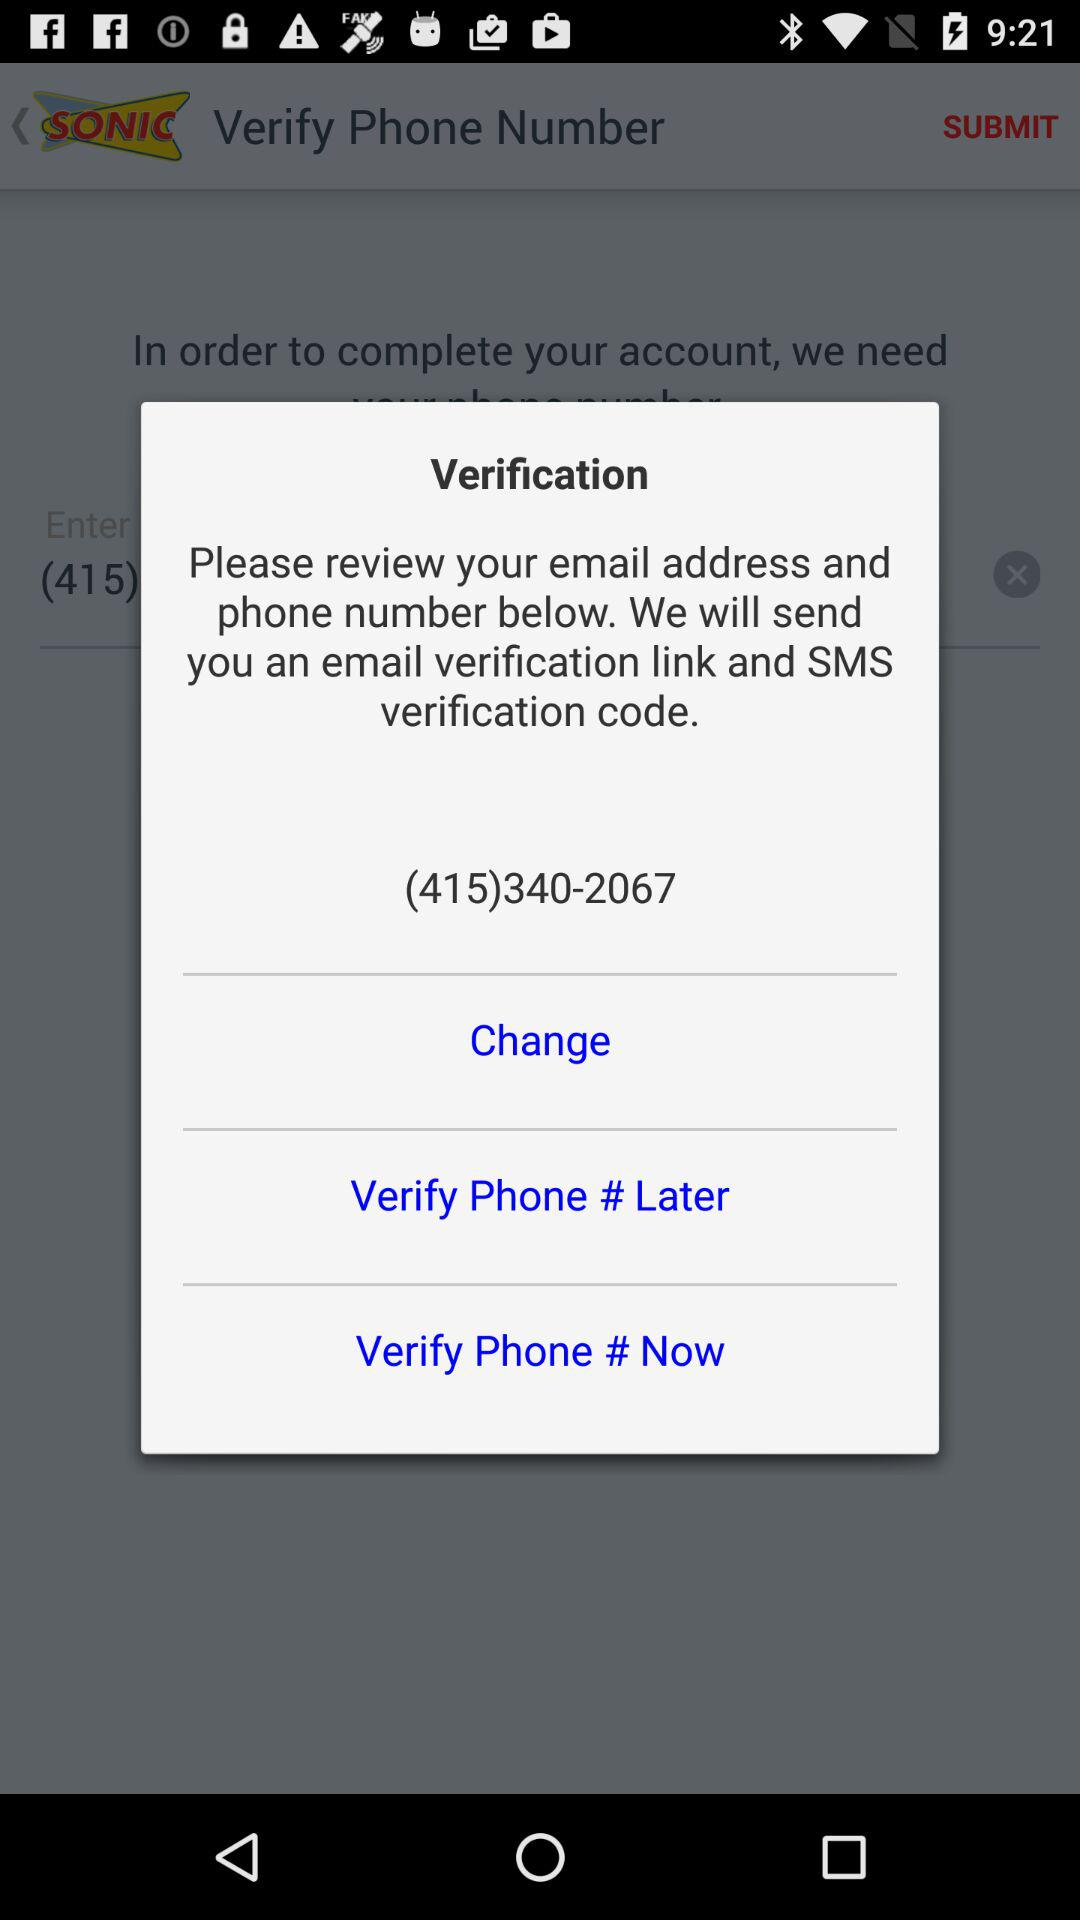How many options are there to verify the phone number?
Answer the question using a single word or phrase. 3 